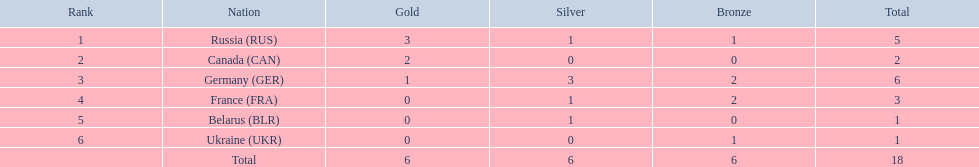What were all the countries that won biathlon medals? Russia (RUS), Canada (CAN), Germany (GER), France (FRA), Belarus (BLR), Ukraine (UKR). What were their medal counts? 5, 2, 6, 3, 1, 1. Of these, which is the largest number of medals? 6. Which country won this number of medals? Germany (GER). 